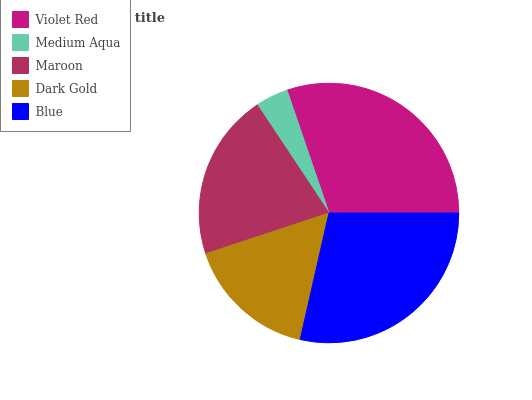Is Medium Aqua the minimum?
Answer yes or no. Yes. Is Violet Red the maximum?
Answer yes or no. Yes. Is Maroon the minimum?
Answer yes or no. No. Is Maroon the maximum?
Answer yes or no. No. Is Maroon greater than Medium Aqua?
Answer yes or no. Yes. Is Medium Aqua less than Maroon?
Answer yes or no. Yes. Is Medium Aqua greater than Maroon?
Answer yes or no. No. Is Maroon less than Medium Aqua?
Answer yes or no. No. Is Maroon the high median?
Answer yes or no. Yes. Is Maroon the low median?
Answer yes or no. Yes. Is Medium Aqua the high median?
Answer yes or no. No. Is Medium Aqua the low median?
Answer yes or no. No. 